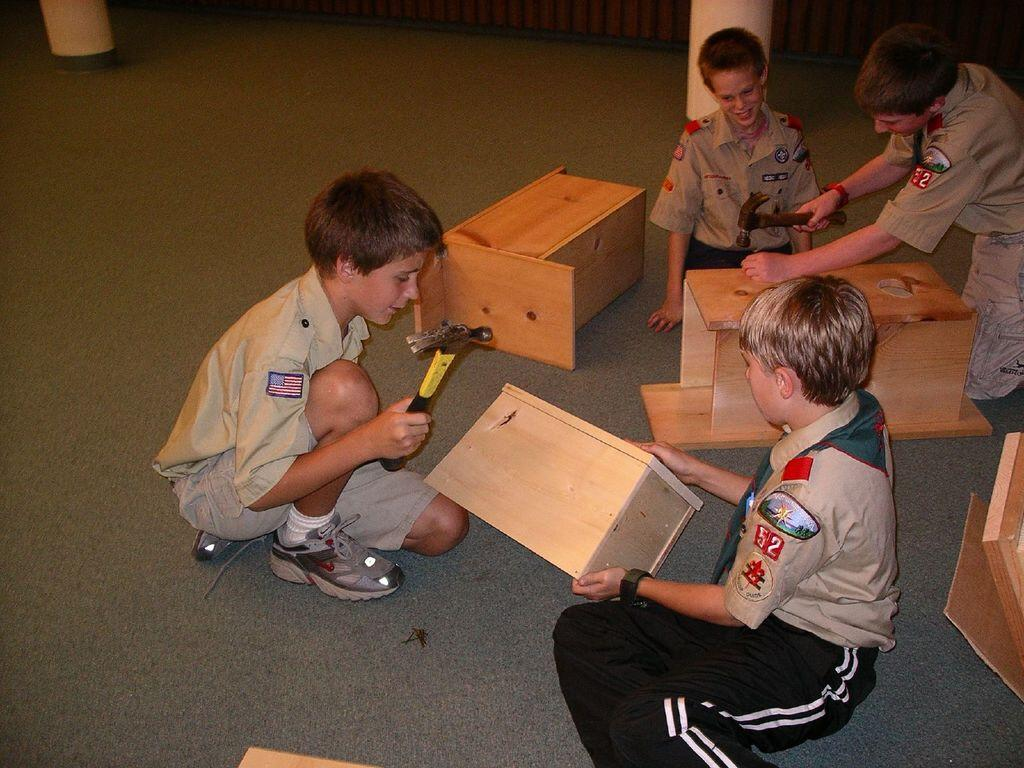Who or what is present in the image? There are people in the image. What tool can be seen in the image? There is a hammer in the image. What type of objects are made of wood in the image? There are wooden objects in the image. What operation is the father performing on the wooden objects in the image? There is no father present in the image, and no operation is being performed on the wooden objects. 